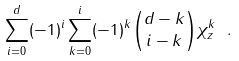Convert formula to latex. <formula><loc_0><loc_0><loc_500><loc_500>\sum _ { i = 0 } ^ { d } ( - 1 ) ^ { i } \sum _ { k = 0 } ^ { i } ( - 1 ) ^ { k } \binom { d - k } { i - k } \chi ^ { k } _ { z } \ .</formula> 